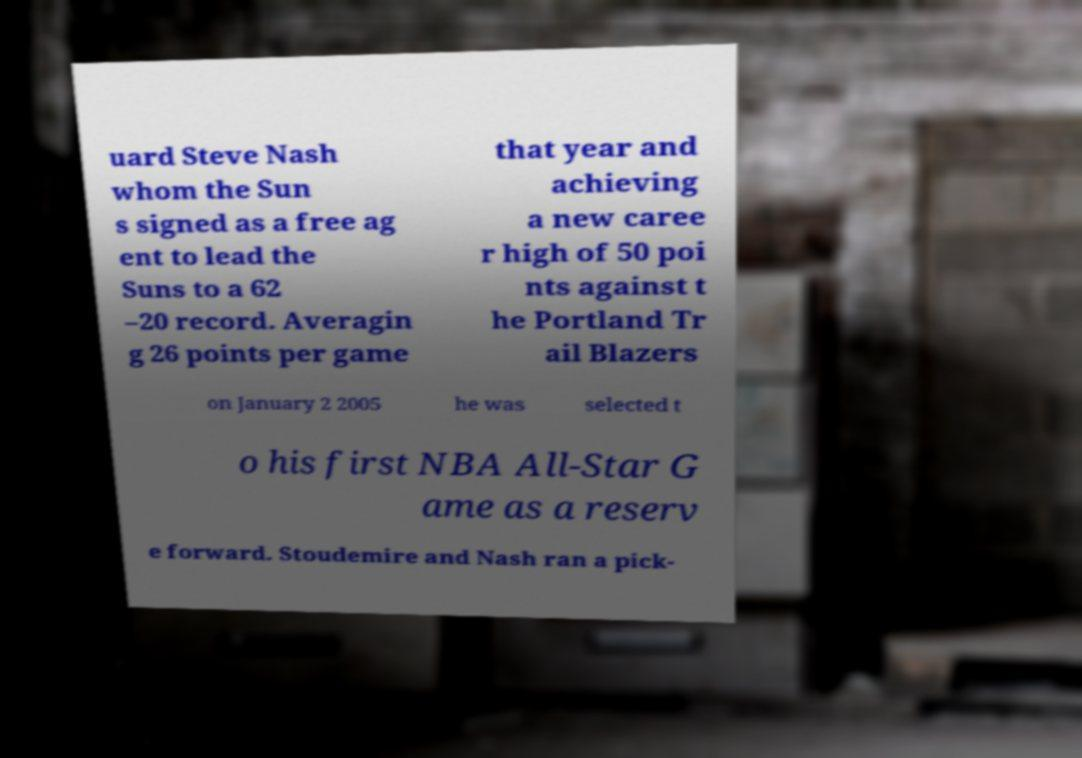Please identify and transcribe the text found in this image. uard Steve Nash whom the Sun s signed as a free ag ent to lead the Suns to a 62 –20 record. Averagin g 26 points per game that year and achieving a new caree r high of 50 poi nts against t he Portland Tr ail Blazers on January 2 2005 he was selected t o his first NBA All-Star G ame as a reserv e forward. Stoudemire and Nash ran a pick- 